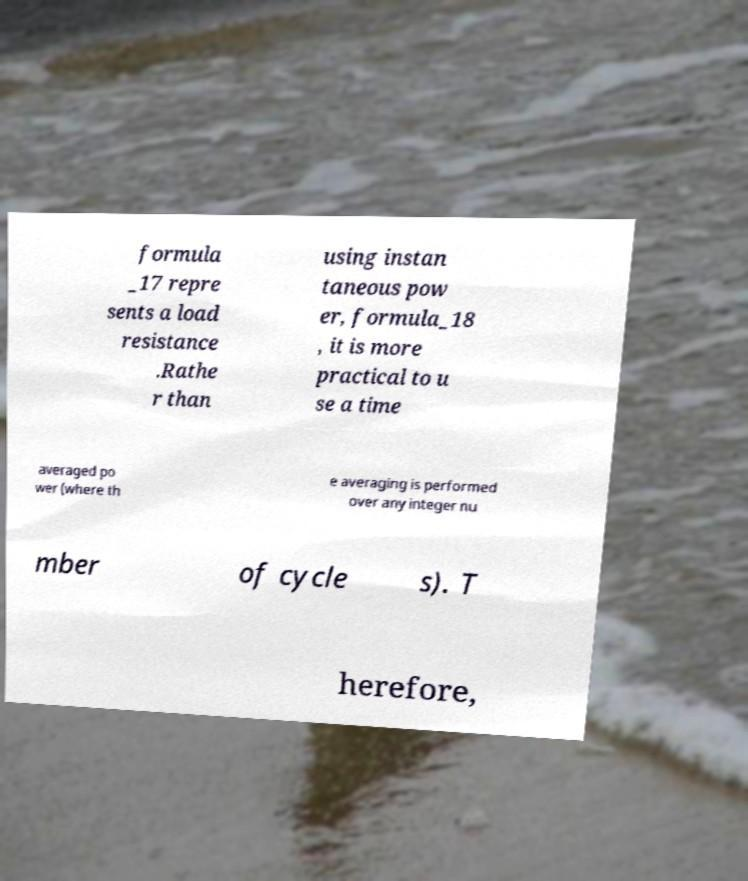Please read and relay the text visible in this image. What does it say? formula _17 repre sents a load resistance .Rathe r than using instan taneous pow er, formula_18 , it is more practical to u se a time averaged po wer (where th e averaging is performed over any integer nu mber of cycle s). T herefore, 